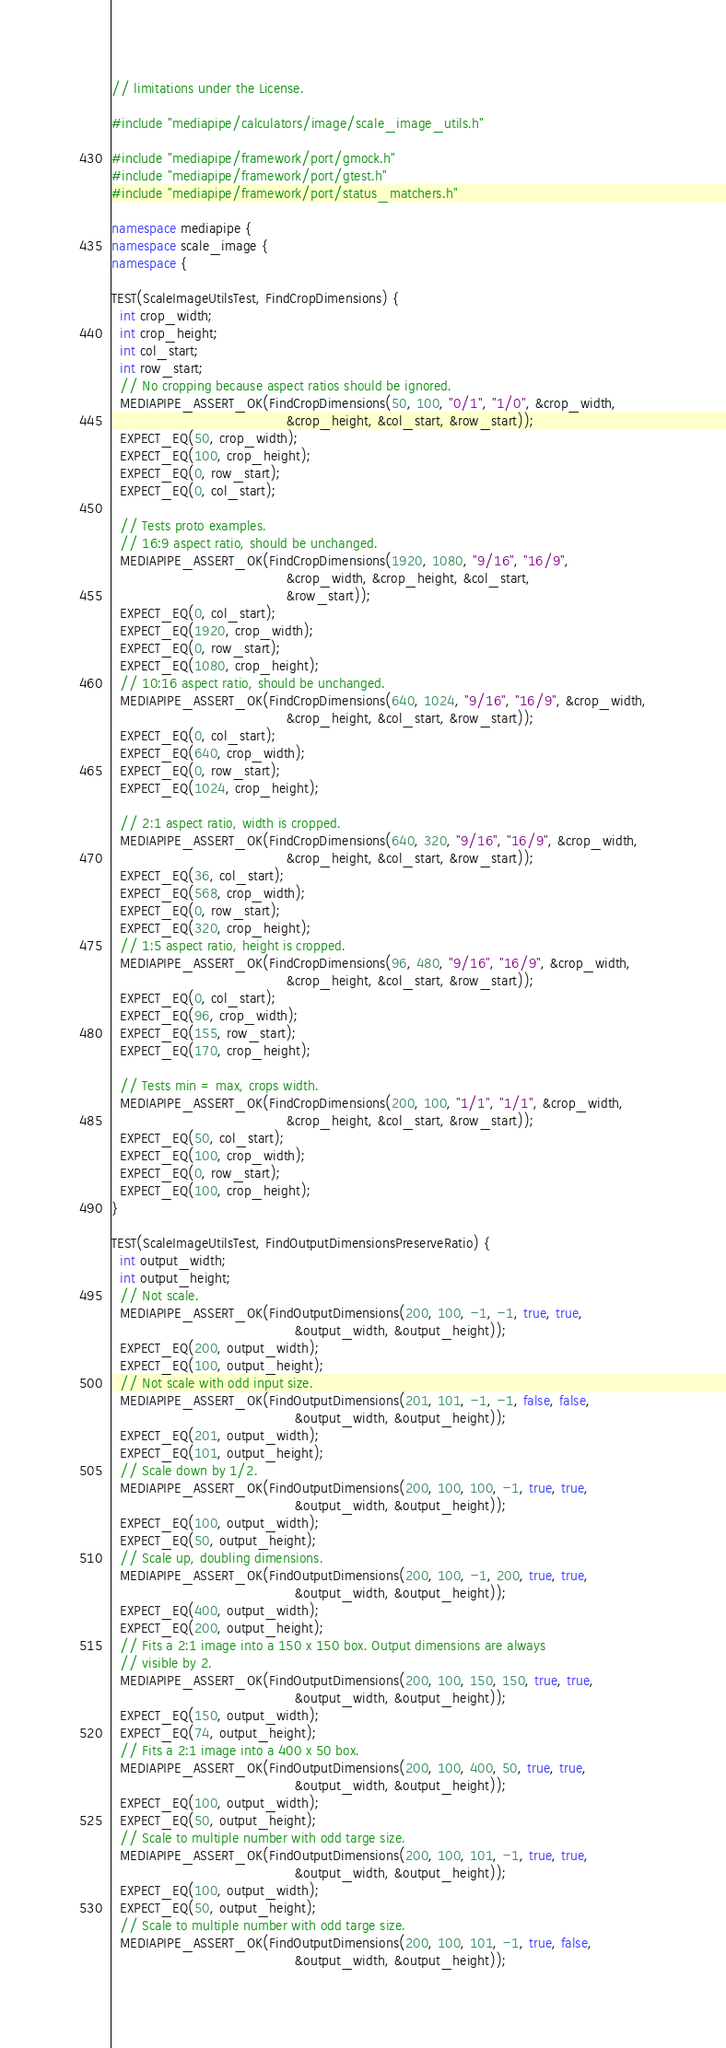Convert code to text. <code><loc_0><loc_0><loc_500><loc_500><_C++_>// limitations under the License.

#include "mediapipe/calculators/image/scale_image_utils.h"

#include "mediapipe/framework/port/gmock.h"
#include "mediapipe/framework/port/gtest.h"
#include "mediapipe/framework/port/status_matchers.h"

namespace mediapipe {
namespace scale_image {
namespace {

TEST(ScaleImageUtilsTest, FindCropDimensions) {
  int crop_width;
  int crop_height;
  int col_start;
  int row_start;
  // No cropping because aspect ratios should be ignored.
  MEDIAPIPE_ASSERT_OK(FindCropDimensions(50, 100, "0/1", "1/0", &crop_width,
                                         &crop_height, &col_start, &row_start));
  EXPECT_EQ(50, crop_width);
  EXPECT_EQ(100, crop_height);
  EXPECT_EQ(0, row_start);
  EXPECT_EQ(0, col_start);

  // Tests proto examples.
  // 16:9 aspect ratio, should be unchanged.
  MEDIAPIPE_ASSERT_OK(FindCropDimensions(1920, 1080, "9/16", "16/9",
                                         &crop_width, &crop_height, &col_start,
                                         &row_start));
  EXPECT_EQ(0, col_start);
  EXPECT_EQ(1920, crop_width);
  EXPECT_EQ(0, row_start);
  EXPECT_EQ(1080, crop_height);
  // 10:16 aspect ratio, should be unchanged.
  MEDIAPIPE_ASSERT_OK(FindCropDimensions(640, 1024, "9/16", "16/9", &crop_width,
                                         &crop_height, &col_start, &row_start));
  EXPECT_EQ(0, col_start);
  EXPECT_EQ(640, crop_width);
  EXPECT_EQ(0, row_start);
  EXPECT_EQ(1024, crop_height);

  // 2:1 aspect ratio, width is cropped.
  MEDIAPIPE_ASSERT_OK(FindCropDimensions(640, 320, "9/16", "16/9", &crop_width,
                                         &crop_height, &col_start, &row_start));
  EXPECT_EQ(36, col_start);
  EXPECT_EQ(568, crop_width);
  EXPECT_EQ(0, row_start);
  EXPECT_EQ(320, crop_height);
  // 1:5 aspect ratio, height is cropped.
  MEDIAPIPE_ASSERT_OK(FindCropDimensions(96, 480, "9/16", "16/9", &crop_width,
                                         &crop_height, &col_start, &row_start));
  EXPECT_EQ(0, col_start);
  EXPECT_EQ(96, crop_width);
  EXPECT_EQ(155, row_start);
  EXPECT_EQ(170, crop_height);

  // Tests min = max, crops width.
  MEDIAPIPE_ASSERT_OK(FindCropDimensions(200, 100, "1/1", "1/1", &crop_width,
                                         &crop_height, &col_start, &row_start));
  EXPECT_EQ(50, col_start);
  EXPECT_EQ(100, crop_width);
  EXPECT_EQ(0, row_start);
  EXPECT_EQ(100, crop_height);
}

TEST(ScaleImageUtilsTest, FindOutputDimensionsPreserveRatio) {
  int output_width;
  int output_height;
  // Not scale.
  MEDIAPIPE_ASSERT_OK(FindOutputDimensions(200, 100, -1, -1, true, true,
                                           &output_width, &output_height));
  EXPECT_EQ(200, output_width);
  EXPECT_EQ(100, output_height);
  // Not scale with odd input size.
  MEDIAPIPE_ASSERT_OK(FindOutputDimensions(201, 101, -1, -1, false, false,
                                           &output_width, &output_height));
  EXPECT_EQ(201, output_width);
  EXPECT_EQ(101, output_height);
  // Scale down by 1/2.
  MEDIAPIPE_ASSERT_OK(FindOutputDimensions(200, 100, 100, -1, true, true,
                                           &output_width, &output_height));
  EXPECT_EQ(100, output_width);
  EXPECT_EQ(50, output_height);
  // Scale up, doubling dimensions.
  MEDIAPIPE_ASSERT_OK(FindOutputDimensions(200, 100, -1, 200, true, true,
                                           &output_width, &output_height));
  EXPECT_EQ(400, output_width);
  EXPECT_EQ(200, output_height);
  // Fits a 2:1 image into a 150 x 150 box. Output dimensions are always
  // visible by 2.
  MEDIAPIPE_ASSERT_OK(FindOutputDimensions(200, 100, 150, 150, true, true,
                                           &output_width, &output_height));
  EXPECT_EQ(150, output_width);
  EXPECT_EQ(74, output_height);
  // Fits a 2:1 image into a 400 x 50 box.
  MEDIAPIPE_ASSERT_OK(FindOutputDimensions(200, 100, 400, 50, true, true,
                                           &output_width, &output_height));
  EXPECT_EQ(100, output_width);
  EXPECT_EQ(50, output_height);
  // Scale to multiple number with odd targe size.
  MEDIAPIPE_ASSERT_OK(FindOutputDimensions(200, 100, 101, -1, true, true,
                                           &output_width, &output_height));
  EXPECT_EQ(100, output_width);
  EXPECT_EQ(50, output_height);
  // Scale to multiple number with odd targe size.
  MEDIAPIPE_ASSERT_OK(FindOutputDimensions(200, 100, 101, -1, true, false,
                                           &output_width, &output_height));</code> 